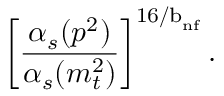<formula> <loc_0><loc_0><loc_500><loc_500>\left [ \frac { \alpha _ { s } ( p ^ { 2 } ) } { \alpha _ { s } ( m _ { t } ^ { 2 } ) } \right ] ^ { { 1 6 / b } _ { n f } } .</formula> 